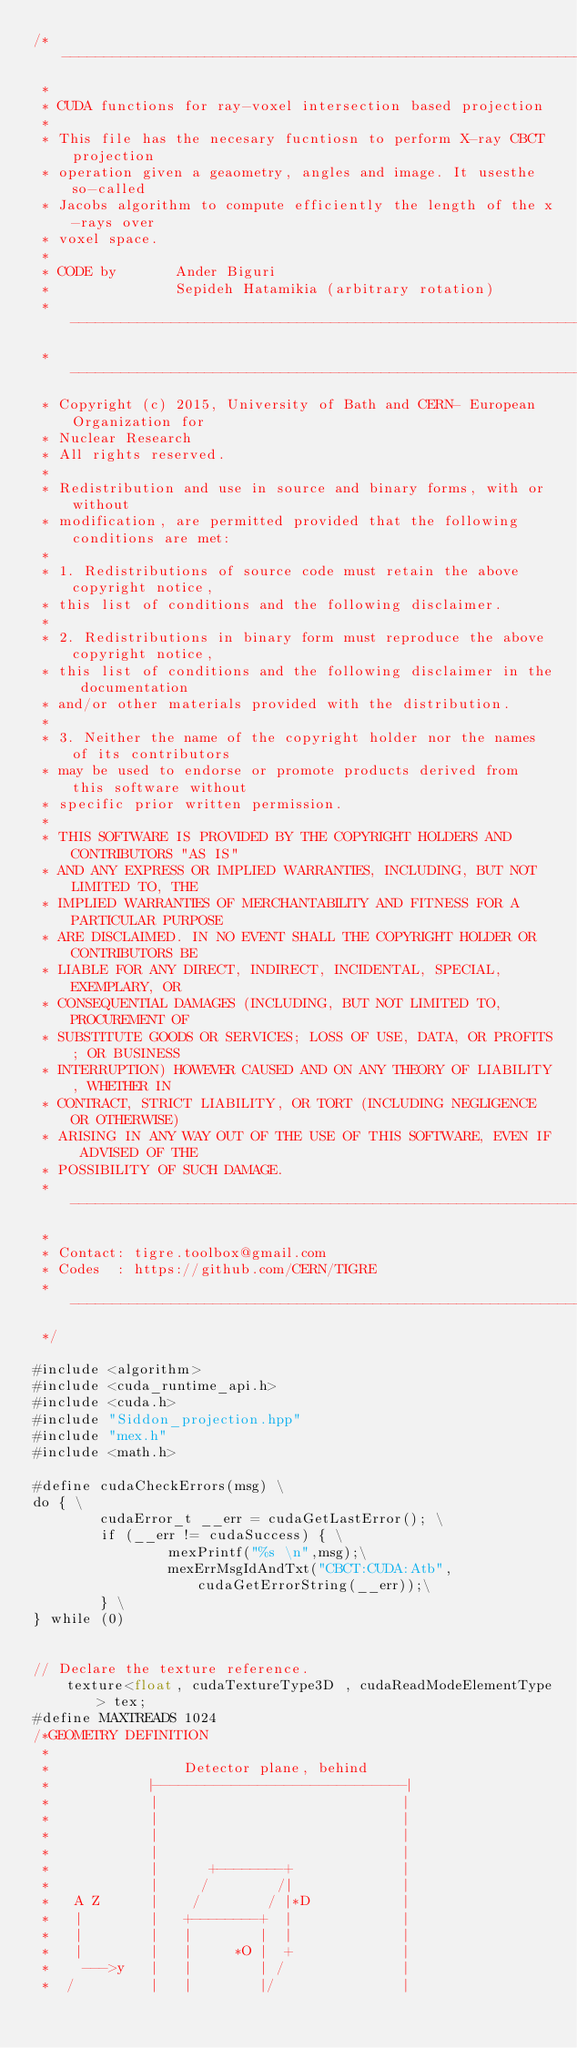<code> <loc_0><loc_0><loc_500><loc_500><_Cuda_>/*-------------------------------------------------------------------------
 *
 * CUDA functions for ray-voxel intersection based projection
 *
 * This file has the necesary fucntiosn to perform X-ray CBCT projection
 * operation given a geaometry, angles and image. It usesthe so-called
 * Jacobs algorithm to compute efficiently the length of the x-rays over
 * voxel space.
 *
 * CODE by       Ander Biguri
 *               Sepideh Hatamikia (arbitrary rotation)
 * ---------------------------------------------------------------------------
 * ---------------------------------------------------------------------------
 * Copyright (c) 2015, University of Bath and CERN- European Organization for
 * Nuclear Research
 * All rights reserved.
 *
 * Redistribution and use in source and binary forms, with or without
 * modification, are permitted provided that the following conditions are met:
 *
 * 1. Redistributions of source code must retain the above copyright notice,
 * this list of conditions and the following disclaimer.
 *
 * 2. Redistributions in binary form must reproduce the above copyright notice,
 * this list of conditions and the following disclaimer in the documentation
 * and/or other materials provided with the distribution.
 *
 * 3. Neither the name of the copyright holder nor the names of its contributors
 * may be used to endorse or promote products derived from this software without
 * specific prior written permission.
 *
 * THIS SOFTWARE IS PROVIDED BY THE COPYRIGHT HOLDERS AND CONTRIBUTORS "AS IS"
 * AND ANY EXPRESS OR IMPLIED WARRANTIES, INCLUDING, BUT NOT LIMITED TO, THE
 * IMPLIED WARRANTIES OF MERCHANTABILITY AND FITNESS FOR A PARTICULAR PURPOSE
 * ARE DISCLAIMED. IN NO EVENT SHALL THE COPYRIGHT HOLDER OR CONTRIBUTORS BE
 * LIABLE FOR ANY DIRECT, INDIRECT, INCIDENTAL, SPECIAL, EXEMPLARY, OR
 * CONSEQUENTIAL DAMAGES (INCLUDING, BUT NOT LIMITED TO, PROCUREMENT OF
 * SUBSTITUTE GOODS OR SERVICES; LOSS OF USE, DATA, OR PROFITS; OR BUSINESS
 * INTERRUPTION) HOWEVER CAUSED AND ON ANY THEORY OF LIABILITY, WHETHER IN
 * CONTRACT, STRICT LIABILITY, OR TORT (INCLUDING NEGLIGENCE OR OTHERWISE)
 * ARISING IN ANY WAY OUT OF THE USE OF THIS SOFTWARE, EVEN IF ADVISED OF THE
 * POSSIBILITY OF SUCH DAMAGE.
 * ---------------------------------------------------------------------------
 *
 * Contact: tigre.toolbox@gmail.com
 * Codes  : https://github.com/CERN/TIGRE
 * ---------------------------------------------------------------------------
 */

#include <algorithm>
#include <cuda_runtime_api.h>
#include <cuda.h>
#include "Siddon_projection.hpp"
#include "mex.h"
#include <math.h>

#define cudaCheckErrors(msg) \
do { \
        cudaError_t __err = cudaGetLastError(); \
        if (__err != cudaSuccess) { \
                mexPrintf("%s \n",msg);\
                mexErrMsgIdAndTxt("CBCT:CUDA:Atb",cudaGetErrorString(__err));\
        } \
} while (0)
    
    
// Declare the texture reference.
    texture<float, cudaTextureType3D , cudaReadModeElementType> tex;
#define MAXTREADS 1024
/*GEOMETRY DEFINITION
 *
 *                Detector plane, behind
 *            |-----------------------------|
 *            |                             |
 *            |                             |
 *            |                             |
 *            |                             |
 *            |      +--------+             |
 *            |     /        /|             |
 *   A Z      |    /        / |*D           |
 *   |        |   +--------+  |             |
 *   |        |   |        |  |             |
 *   |        |   |     *O |  +             |
 *    --->y   |   |        | /              |
 *  /         |   |        |/               |</code> 